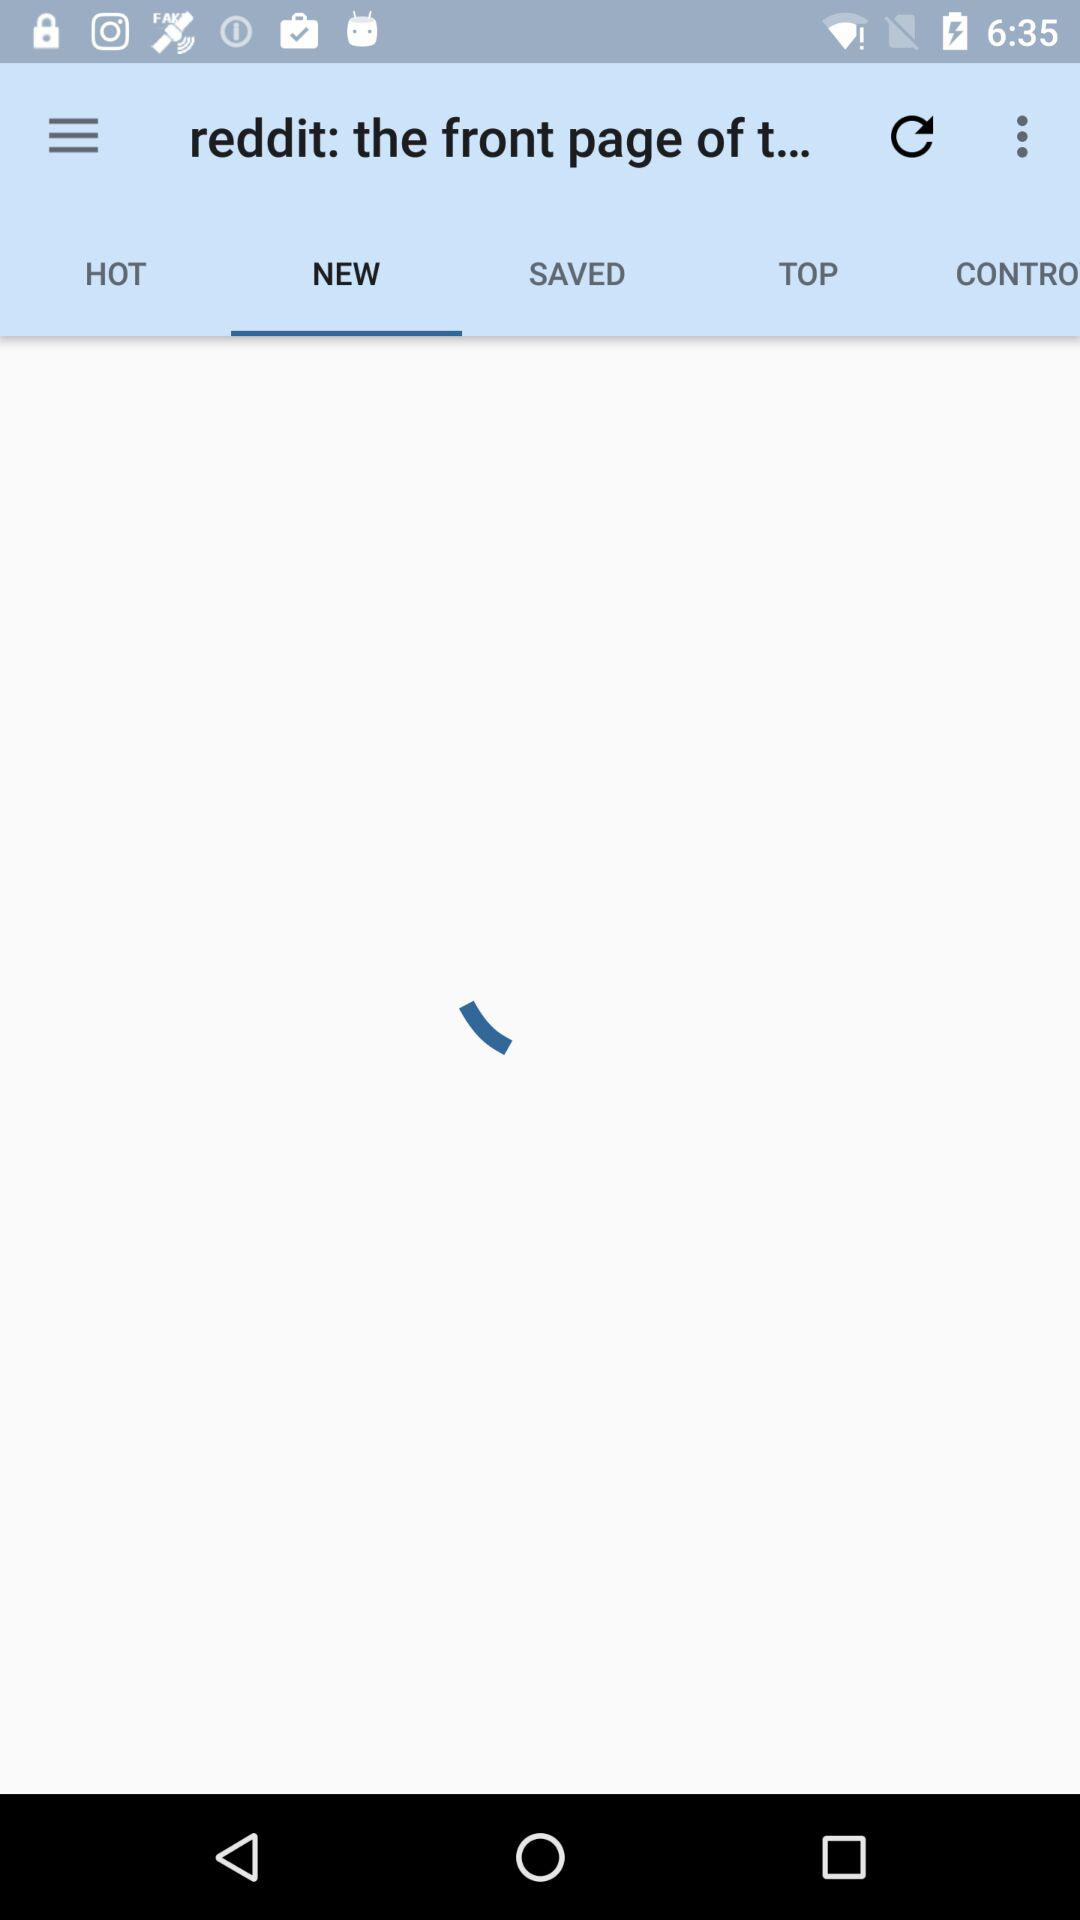Which tab has been selected? The selected tab is "NEW". 